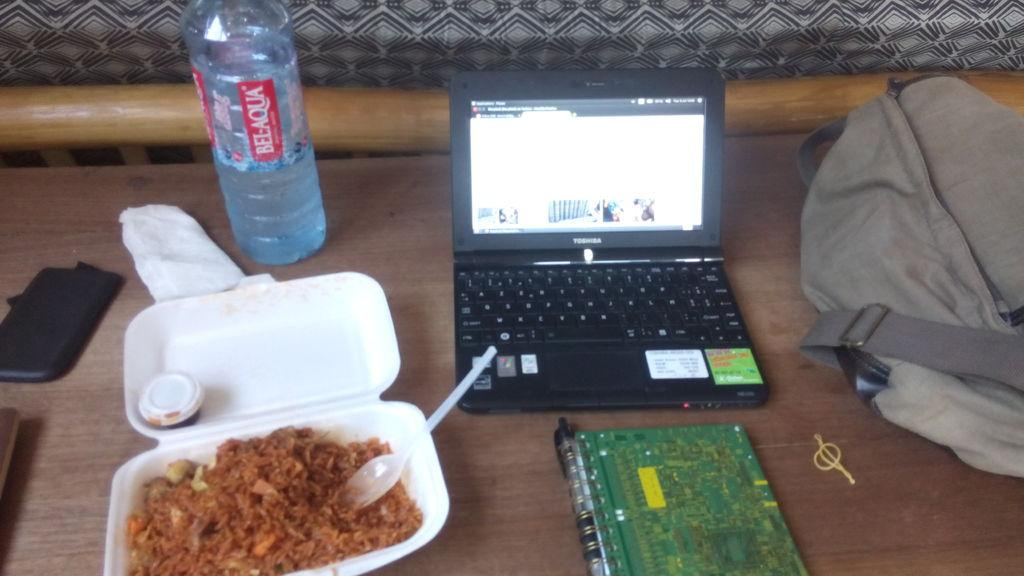<image>
Summarize the visual content of the image. a person eating chinese food with bel aqua water and working on the computer. 